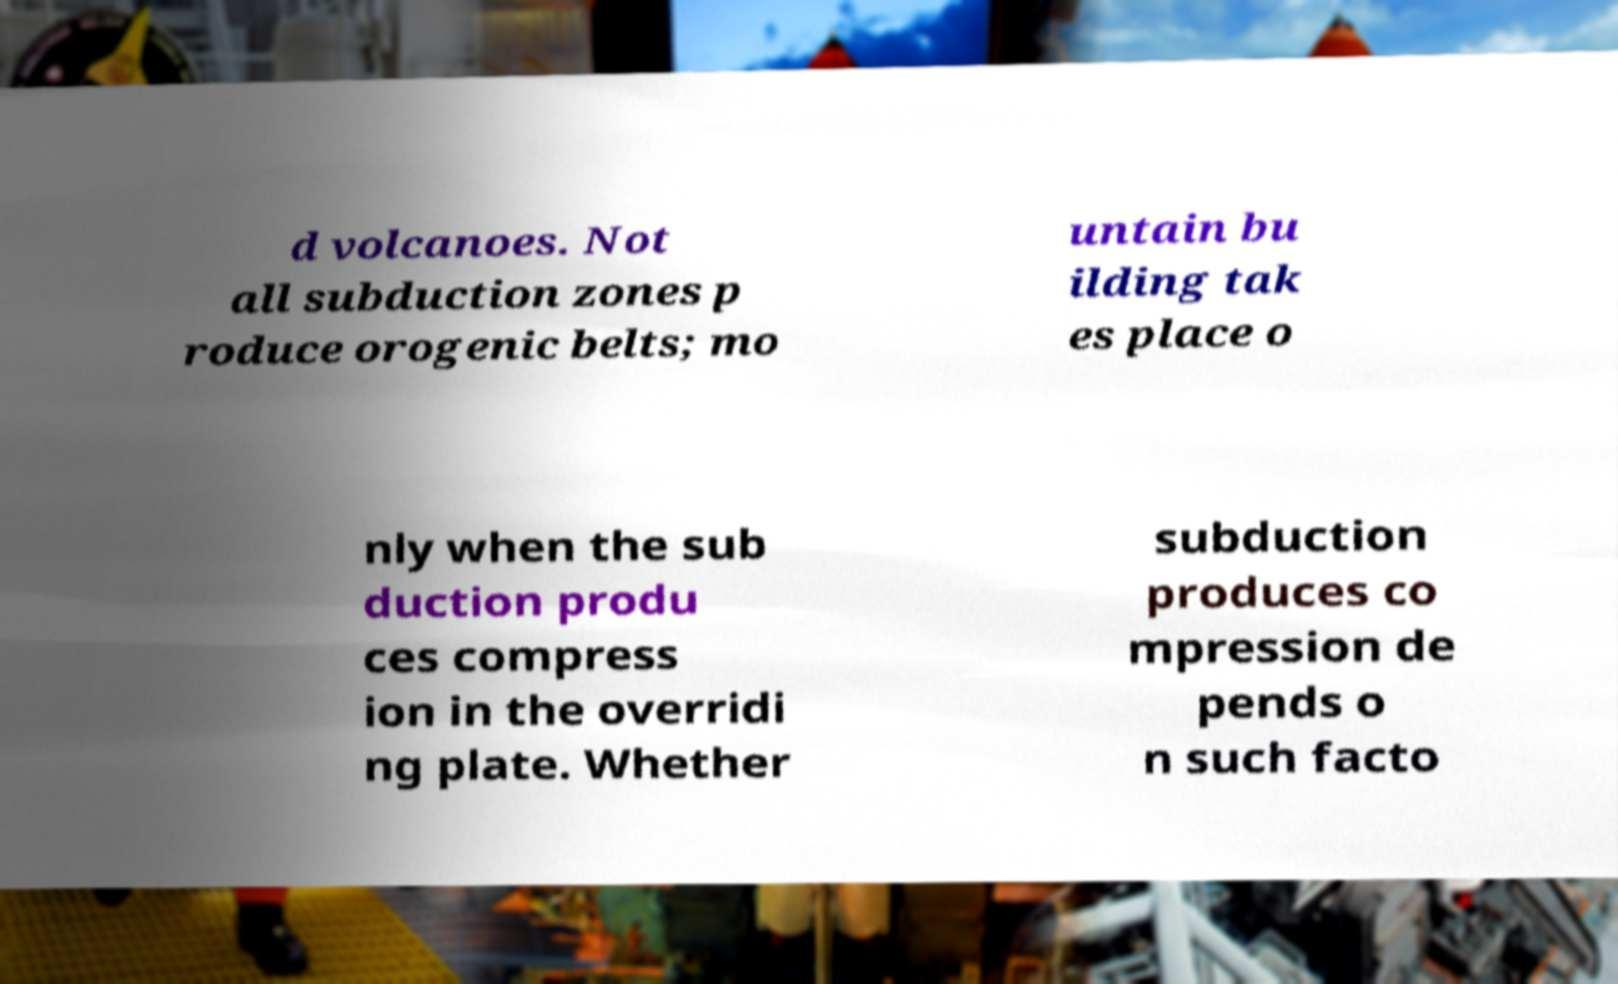For documentation purposes, I need the text within this image transcribed. Could you provide that? d volcanoes. Not all subduction zones p roduce orogenic belts; mo untain bu ilding tak es place o nly when the sub duction produ ces compress ion in the overridi ng plate. Whether subduction produces co mpression de pends o n such facto 